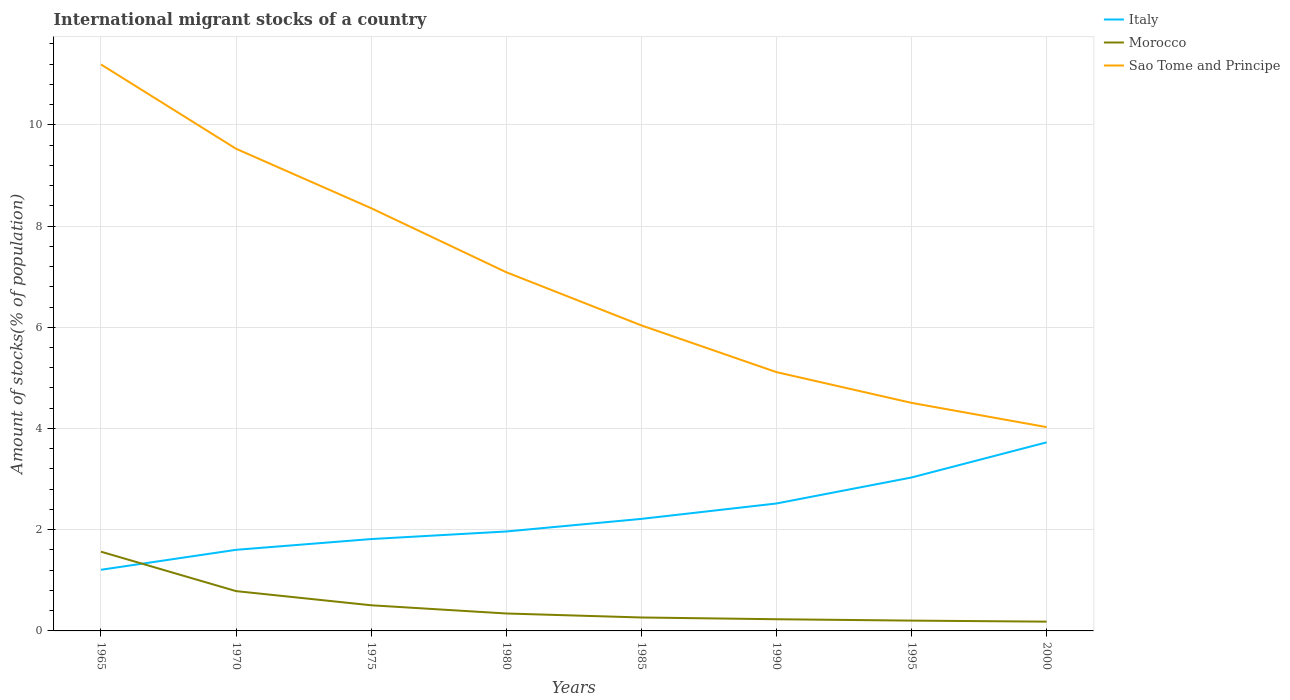Does the line corresponding to Sao Tome and Principe intersect with the line corresponding to Italy?
Your response must be concise. No. Across all years, what is the maximum amount of stocks in in Sao Tome and Principe?
Offer a very short reply. 4.03. In which year was the amount of stocks in in Italy maximum?
Provide a succinct answer. 1965. What is the total amount of stocks in in Sao Tome and Principe in the graph?
Provide a succinct answer. 6.69. What is the difference between the highest and the second highest amount of stocks in in Italy?
Your answer should be very brief. 2.52. What is the difference between the highest and the lowest amount of stocks in in Morocco?
Keep it short and to the point. 2. How many years are there in the graph?
Your answer should be compact. 8. Where does the legend appear in the graph?
Give a very brief answer. Top right. What is the title of the graph?
Provide a short and direct response. International migrant stocks of a country. What is the label or title of the X-axis?
Provide a succinct answer. Years. What is the label or title of the Y-axis?
Your response must be concise. Amount of stocks(% of population). What is the Amount of stocks(% of population) in Italy in 1965?
Your response must be concise. 1.21. What is the Amount of stocks(% of population) of Morocco in 1965?
Provide a succinct answer. 1.57. What is the Amount of stocks(% of population) in Sao Tome and Principe in 1965?
Give a very brief answer. 11.19. What is the Amount of stocks(% of population) of Italy in 1970?
Keep it short and to the point. 1.6. What is the Amount of stocks(% of population) of Morocco in 1970?
Offer a very short reply. 0.79. What is the Amount of stocks(% of population) in Sao Tome and Principe in 1970?
Offer a terse response. 9.53. What is the Amount of stocks(% of population) in Italy in 1975?
Your answer should be compact. 1.82. What is the Amount of stocks(% of population) of Morocco in 1975?
Offer a terse response. 0.51. What is the Amount of stocks(% of population) of Sao Tome and Principe in 1975?
Provide a short and direct response. 8.35. What is the Amount of stocks(% of population) of Italy in 1980?
Make the answer very short. 1.96. What is the Amount of stocks(% of population) in Morocco in 1980?
Provide a succinct answer. 0.34. What is the Amount of stocks(% of population) of Sao Tome and Principe in 1980?
Provide a succinct answer. 7.09. What is the Amount of stocks(% of population) of Italy in 1985?
Offer a very short reply. 2.21. What is the Amount of stocks(% of population) in Morocco in 1985?
Your answer should be very brief. 0.27. What is the Amount of stocks(% of population) of Sao Tome and Principe in 1985?
Ensure brevity in your answer.  6.04. What is the Amount of stocks(% of population) of Italy in 1990?
Provide a succinct answer. 2.52. What is the Amount of stocks(% of population) of Morocco in 1990?
Your response must be concise. 0.23. What is the Amount of stocks(% of population) in Sao Tome and Principe in 1990?
Make the answer very short. 5.11. What is the Amount of stocks(% of population) of Italy in 1995?
Offer a very short reply. 3.03. What is the Amount of stocks(% of population) in Morocco in 1995?
Provide a succinct answer. 0.2. What is the Amount of stocks(% of population) of Sao Tome and Principe in 1995?
Provide a short and direct response. 4.51. What is the Amount of stocks(% of population) in Italy in 2000?
Provide a succinct answer. 3.73. What is the Amount of stocks(% of population) of Morocco in 2000?
Your response must be concise. 0.18. What is the Amount of stocks(% of population) of Sao Tome and Principe in 2000?
Offer a very short reply. 4.03. Across all years, what is the maximum Amount of stocks(% of population) in Italy?
Your response must be concise. 3.73. Across all years, what is the maximum Amount of stocks(% of population) of Morocco?
Make the answer very short. 1.57. Across all years, what is the maximum Amount of stocks(% of population) in Sao Tome and Principe?
Offer a terse response. 11.19. Across all years, what is the minimum Amount of stocks(% of population) of Italy?
Ensure brevity in your answer.  1.21. Across all years, what is the minimum Amount of stocks(% of population) of Morocco?
Provide a succinct answer. 0.18. Across all years, what is the minimum Amount of stocks(% of population) of Sao Tome and Principe?
Keep it short and to the point. 4.03. What is the total Amount of stocks(% of population) in Italy in the graph?
Offer a terse response. 18.08. What is the total Amount of stocks(% of population) in Morocco in the graph?
Offer a terse response. 4.09. What is the total Amount of stocks(% of population) in Sao Tome and Principe in the graph?
Your response must be concise. 55.85. What is the difference between the Amount of stocks(% of population) in Italy in 1965 and that in 1970?
Your answer should be compact. -0.39. What is the difference between the Amount of stocks(% of population) of Morocco in 1965 and that in 1970?
Make the answer very short. 0.78. What is the difference between the Amount of stocks(% of population) of Sao Tome and Principe in 1965 and that in 1970?
Give a very brief answer. 1.67. What is the difference between the Amount of stocks(% of population) of Italy in 1965 and that in 1975?
Keep it short and to the point. -0.61. What is the difference between the Amount of stocks(% of population) of Morocco in 1965 and that in 1975?
Make the answer very short. 1.06. What is the difference between the Amount of stocks(% of population) of Sao Tome and Principe in 1965 and that in 1975?
Provide a short and direct response. 2.84. What is the difference between the Amount of stocks(% of population) of Italy in 1965 and that in 1980?
Your answer should be compact. -0.76. What is the difference between the Amount of stocks(% of population) of Morocco in 1965 and that in 1980?
Make the answer very short. 1.22. What is the difference between the Amount of stocks(% of population) of Sao Tome and Principe in 1965 and that in 1980?
Keep it short and to the point. 4.11. What is the difference between the Amount of stocks(% of population) of Italy in 1965 and that in 1985?
Give a very brief answer. -1.01. What is the difference between the Amount of stocks(% of population) in Morocco in 1965 and that in 1985?
Give a very brief answer. 1.3. What is the difference between the Amount of stocks(% of population) in Sao Tome and Principe in 1965 and that in 1985?
Provide a short and direct response. 5.16. What is the difference between the Amount of stocks(% of population) of Italy in 1965 and that in 1990?
Offer a terse response. -1.31. What is the difference between the Amount of stocks(% of population) of Morocco in 1965 and that in 1990?
Your answer should be very brief. 1.33. What is the difference between the Amount of stocks(% of population) of Sao Tome and Principe in 1965 and that in 1990?
Offer a terse response. 6.08. What is the difference between the Amount of stocks(% of population) in Italy in 1965 and that in 1995?
Make the answer very short. -1.82. What is the difference between the Amount of stocks(% of population) in Morocco in 1965 and that in 1995?
Offer a very short reply. 1.36. What is the difference between the Amount of stocks(% of population) of Sao Tome and Principe in 1965 and that in 1995?
Provide a succinct answer. 6.69. What is the difference between the Amount of stocks(% of population) in Italy in 1965 and that in 2000?
Provide a succinct answer. -2.52. What is the difference between the Amount of stocks(% of population) of Morocco in 1965 and that in 2000?
Ensure brevity in your answer.  1.38. What is the difference between the Amount of stocks(% of population) in Sao Tome and Principe in 1965 and that in 2000?
Offer a terse response. 7.17. What is the difference between the Amount of stocks(% of population) of Italy in 1970 and that in 1975?
Offer a very short reply. -0.21. What is the difference between the Amount of stocks(% of population) in Morocco in 1970 and that in 1975?
Give a very brief answer. 0.28. What is the difference between the Amount of stocks(% of population) in Sao Tome and Principe in 1970 and that in 1975?
Ensure brevity in your answer.  1.17. What is the difference between the Amount of stocks(% of population) of Italy in 1970 and that in 1980?
Make the answer very short. -0.36. What is the difference between the Amount of stocks(% of population) in Morocco in 1970 and that in 1980?
Provide a succinct answer. 0.44. What is the difference between the Amount of stocks(% of population) in Sao Tome and Principe in 1970 and that in 1980?
Keep it short and to the point. 2.44. What is the difference between the Amount of stocks(% of population) in Italy in 1970 and that in 1985?
Your answer should be compact. -0.61. What is the difference between the Amount of stocks(% of population) of Morocco in 1970 and that in 1985?
Your response must be concise. 0.52. What is the difference between the Amount of stocks(% of population) of Sao Tome and Principe in 1970 and that in 1985?
Your response must be concise. 3.49. What is the difference between the Amount of stocks(% of population) in Italy in 1970 and that in 1990?
Your answer should be very brief. -0.92. What is the difference between the Amount of stocks(% of population) in Morocco in 1970 and that in 1990?
Provide a succinct answer. 0.56. What is the difference between the Amount of stocks(% of population) of Sao Tome and Principe in 1970 and that in 1990?
Give a very brief answer. 4.41. What is the difference between the Amount of stocks(% of population) in Italy in 1970 and that in 1995?
Keep it short and to the point. -1.43. What is the difference between the Amount of stocks(% of population) in Morocco in 1970 and that in 1995?
Make the answer very short. 0.58. What is the difference between the Amount of stocks(% of population) in Sao Tome and Principe in 1970 and that in 1995?
Make the answer very short. 5.02. What is the difference between the Amount of stocks(% of population) in Italy in 1970 and that in 2000?
Offer a very short reply. -2.12. What is the difference between the Amount of stocks(% of population) in Morocco in 1970 and that in 2000?
Ensure brevity in your answer.  0.6. What is the difference between the Amount of stocks(% of population) in Sao Tome and Principe in 1970 and that in 2000?
Your answer should be very brief. 5.5. What is the difference between the Amount of stocks(% of population) in Italy in 1975 and that in 1980?
Keep it short and to the point. -0.15. What is the difference between the Amount of stocks(% of population) in Morocco in 1975 and that in 1980?
Make the answer very short. 0.16. What is the difference between the Amount of stocks(% of population) in Sao Tome and Principe in 1975 and that in 1980?
Provide a short and direct response. 1.27. What is the difference between the Amount of stocks(% of population) in Italy in 1975 and that in 1985?
Provide a short and direct response. -0.4. What is the difference between the Amount of stocks(% of population) of Morocco in 1975 and that in 1985?
Your answer should be very brief. 0.24. What is the difference between the Amount of stocks(% of population) in Sao Tome and Principe in 1975 and that in 1985?
Give a very brief answer. 2.32. What is the difference between the Amount of stocks(% of population) of Italy in 1975 and that in 1990?
Your answer should be very brief. -0.7. What is the difference between the Amount of stocks(% of population) of Morocco in 1975 and that in 1990?
Offer a very short reply. 0.28. What is the difference between the Amount of stocks(% of population) in Sao Tome and Principe in 1975 and that in 1990?
Make the answer very short. 3.24. What is the difference between the Amount of stocks(% of population) in Italy in 1975 and that in 1995?
Your answer should be very brief. -1.22. What is the difference between the Amount of stocks(% of population) of Morocco in 1975 and that in 1995?
Offer a very short reply. 0.3. What is the difference between the Amount of stocks(% of population) in Sao Tome and Principe in 1975 and that in 1995?
Make the answer very short. 3.85. What is the difference between the Amount of stocks(% of population) of Italy in 1975 and that in 2000?
Provide a succinct answer. -1.91. What is the difference between the Amount of stocks(% of population) in Morocco in 1975 and that in 2000?
Keep it short and to the point. 0.32. What is the difference between the Amount of stocks(% of population) of Sao Tome and Principe in 1975 and that in 2000?
Provide a short and direct response. 4.33. What is the difference between the Amount of stocks(% of population) of Italy in 1980 and that in 1985?
Your response must be concise. -0.25. What is the difference between the Amount of stocks(% of population) of Morocco in 1980 and that in 1985?
Keep it short and to the point. 0.08. What is the difference between the Amount of stocks(% of population) in Sao Tome and Principe in 1980 and that in 1985?
Provide a succinct answer. 1.05. What is the difference between the Amount of stocks(% of population) in Italy in 1980 and that in 1990?
Provide a short and direct response. -0.55. What is the difference between the Amount of stocks(% of population) of Morocco in 1980 and that in 1990?
Ensure brevity in your answer.  0.11. What is the difference between the Amount of stocks(% of population) of Sao Tome and Principe in 1980 and that in 1990?
Make the answer very short. 1.97. What is the difference between the Amount of stocks(% of population) in Italy in 1980 and that in 1995?
Your response must be concise. -1.07. What is the difference between the Amount of stocks(% of population) in Morocco in 1980 and that in 1995?
Your answer should be very brief. 0.14. What is the difference between the Amount of stocks(% of population) of Sao Tome and Principe in 1980 and that in 1995?
Keep it short and to the point. 2.58. What is the difference between the Amount of stocks(% of population) in Italy in 1980 and that in 2000?
Offer a terse response. -1.76. What is the difference between the Amount of stocks(% of population) of Morocco in 1980 and that in 2000?
Keep it short and to the point. 0.16. What is the difference between the Amount of stocks(% of population) of Sao Tome and Principe in 1980 and that in 2000?
Make the answer very short. 3.06. What is the difference between the Amount of stocks(% of population) of Italy in 1985 and that in 1990?
Your answer should be compact. -0.3. What is the difference between the Amount of stocks(% of population) of Morocco in 1985 and that in 1990?
Your response must be concise. 0.03. What is the difference between the Amount of stocks(% of population) of Sao Tome and Principe in 1985 and that in 1990?
Make the answer very short. 0.92. What is the difference between the Amount of stocks(% of population) in Italy in 1985 and that in 1995?
Make the answer very short. -0.82. What is the difference between the Amount of stocks(% of population) in Morocco in 1985 and that in 1995?
Your answer should be very brief. 0.06. What is the difference between the Amount of stocks(% of population) in Sao Tome and Principe in 1985 and that in 1995?
Ensure brevity in your answer.  1.53. What is the difference between the Amount of stocks(% of population) in Italy in 1985 and that in 2000?
Your answer should be very brief. -1.51. What is the difference between the Amount of stocks(% of population) in Morocco in 1985 and that in 2000?
Ensure brevity in your answer.  0.08. What is the difference between the Amount of stocks(% of population) in Sao Tome and Principe in 1985 and that in 2000?
Make the answer very short. 2.01. What is the difference between the Amount of stocks(% of population) of Italy in 1990 and that in 1995?
Make the answer very short. -0.51. What is the difference between the Amount of stocks(% of population) in Morocco in 1990 and that in 1995?
Ensure brevity in your answer.  0.03. What is the difference between the Amount of stocks(% of population) in Sao Tome and Principe in 1990 and that in 1995?
Offer a terse response. 0.61. What is the difference between the Amount of stocks(% of population) of Italy in 1990 and that in 2000?
Give a very brief answer. -1.21. What is the difference between the Amount of stocks(% of population) of Morocco in 1990 and that in 2000?
Keep it short and to the point. 0.05. What is the difference between the Amount of stocks(% of population) of Sao Tome and Principe in 1990 and that in 2000?
Offer a terse response. 1.09. What is the difference between the Amount of stocks(% of population) of Italy in 1995 and that in 2000?
Your response must be concise. -0.69. What is the difference between the Amount of stocks(% of population) of Morocco in 1995 and that in 2000?
Offer a very short reply. 0.02. What is the difference between the Amount of stocks(% of population) in Sao Tome and Principe in 1995 and that in 2000?
Your answer should be compact. 0.48. What is the difference between the Amount of stocks(% of population) of Italy in 1965 and the Amount of stocks(% of population) of Morocco in 1970?
Your answer should be compact. 0.42. What is the difference between the Amount of stocks(% of population) of Italy in 1965 and the Amount of stocks(% of population) of Sao Tome and Principe in 1970?
Offer a terse response. -8.32. What is the difference between the Amount of stocks(% of population) of Morocco in 1965 and the Amount of stocks(% of population) of Sao Tome and Principe in 1970?
Make the answer very short. -7.96. What is the difference between the Amount of stocks(% of population) of Italy in 1965 and the Amount of stocks(% of population) of Morocco in 1975?
Your answer should be very brief. 0.7. What is the difference between the Amount of stocks(% of population) in Italy in 1965 and the Amount of stocks(% of population) in Sao Tome and Principe in 1975?
Your response must be concise. -7.14. What is the difference between the Amount of stocks(% of population) of Morocco in 1965 and the Amount of stocks(% of population) of Sao Tome and Principe in 1975?
Keep it short and to the point. -6.79. What is the difference between the Amount of stocks(% of population) of Italy in 1965 and the Amount of stocks(% of population) of Morocco in 1980?
Give a very brief answer. 0.86. What is the difference between the Amount of stocks(% of population) of Italy in 1965 and the Amount of stocks(% of population) of Sao Tome and Principe in 1980?
Offer a very short reply. -5.88. What is the difference between the Amount of stocks(% of population) of Morocco in 1965 and the Amount of stocks(% of population) of Sao Tome and Principe in 1980?
Your answer should be very brief. -5.52. What is the difference between the Amount of stocks(% of population) in Italy in 1965 and the Amount of stocks(% of population) in Morocco in 1985?
Give a very brief answer. 0.94. What is the difference between the Amount of stocks(% of population) of Italy in 1965 and the Amount of stocks(% of population) of Sao Tome and Principe in 1985?
Give a very brief answer. -4.83. What is the difference between the Amount of stocks(% of population) in Morocco in 1965 and the Amount of stocks(% of population) in Sao Tome and Principe in 1985?
Keep it short and to the point. -4.47. What is the difference between the Amount of stocks(% of population) of Italy in 1965 and the Amount of stocks(% of population) of Morocco in 1990?
Provide a succinct answer. 0.98. What is the difference between the Amount of stocks(% of population) in Italy in 1965 and the Amount of stocks(% of population) in Sao Tome and Principe in 1990?
Provide a short and direct response. -3.91. What is the difference between the Amount of stocks(% of population) in Morocco in 1965 and the Amount of stocks(% of population) in Sao Tome and Principe in 1990?
Keep it short and to the point. -3.55. What is the difference between the Amount of stocks(% of population) of Italy in 1965 and the Amount of stocks(% of population) of Morocco in 1995?
Ensure brevity in your answer.  1. What is the difference between the Amount of stocks(% of population) in Italy in 1965 and the Amount of stocks(% of population) in Sao Tome and Principe in 1995?
Your response must be concise. -3.3. What is the difference between the Amount of stocks(% of population) in Morocco in 1965 and the Amount of stocks(% of population) in Sao Tome and Principe in 1995?
Offer a terse response. -2.94. What is the difference between the Amount of stocks(% of population) in Italy in 1965 and the Amount of stocks(% of population) in Morocco in 2000?
Ensure brevity in your answer.  1.02. What is the difference between the Amount of stocks(% of population) in Italy in 1965 and the Amount of stocks(% of population) in Sao Tome and Principe in 2000?
Your answer should be compact. -2.82. What is the difference between the Amount of stocks(% of population) in Morocco in 1965 and the Amount of stocks(% of population) in Sao Tome and Principe in 2000?
Provide a short and direct response. -2.46. What is the difference between the Amount of stocks(% of population) of Italy in 1970 and the Amount of stocks(% of population) of Morocco in 1975?
Provide a short and direct response. 1.1. What is the difference between the Amount of stocks(% of population) in Italy in 1970 and the Amount of stocks(% of population) in Sao Tome and Principe in 1975?
Your answer should be very brief. -6.75. What is the difference between the Amount of stocks(% of population) of Morocco in 1970 and the Amount of stocks(% of population) of Sao Tome and Principe in 1975?
Your answer should be very brief. -7.57. What is the difference between the Amount of stocks(% of population) of Italy in 1970 and the Amount of stocks(% of population) of Morocco in 1980?
Your answer should be very brief. 1.26. What is the difference between the Amount of stocks(% of population) in Italy in 1970 and the Amount of stocks(% of population) in Sao Tome and Principe in 1980?
Keep it short and to the point. -5.49. What is the difference between the Amount of stocks(% of population) of Morocco in 1970 and the Amount of stocks(% of population) of Sao Tome and Principe in 1980?
Your answer should be very brief. -6.3. What is the difference between the Amount of stocks(% of population) of Italy in 1970 and the Amount of stocks(% of population) of Morocco in 1985?
Ensure brevity in your answer.  1.34. What is the difference between the Amount of stocks(% of population) of Italy in 1970 and the Amount of stocks(% of population) of Sao Tome and Principe in 1985?
Provide a succinct answer. -4.43. What is the difference between the Amount of stocks(% of population) of Morocco in 1970 and the Amount of stocks(% of population) of Sao Tome and Principe in 1985?
Offer a terse response. -5.25. What is the difference between the Amount of stocks(% of population) of Italy in 1970 and the Amount of stocks(% of population) of Morocco in 1990?
Make the answer very short. 1.37. What is the difference between the Amount of stocks(% of population) in Italy in 1970 and the Amount of stocks(% of population) in Sao Tome and Principe in 1990?
Offer a terse response. -3.51. What is the difference between the Amount of stocks(% of population) in Morocco in 1970 and the Amount of stocks(% of population) in Sao Tome and Principe in 1990?
Offer a very short reply. -4.33. What is the difference between the Amount of stocks(% of population) of Italy in 1970 and the Amount of stocks(% of population) of Morocco in 1995?
Your response must be concise. 1.4. What is the difference between the Amount of stocks(% of population) in Italy in 1970 and the Amount of stocks(% of population) in Sao Tome and Principe in 1995?
Offer a very short reply. -2.9. What is the difference between the Amount of stocks(% of population) of Morocco in 1970 and the Amount of stocks(% of population) of Sao Tome and Principe in 1995?
Give a very brief answer. -3.72. What is the difference between the Amount of stocks(% of population) of Italy in 1970 and the Amount of stocks(% of population) of Morocco in 2000?
Offer a terse response. 1.42. What is the difference between the Amount of stocks(% of population) in Italy in 1970 and the Amount of stocks(% of population) in Sao Tome and Principe in 2000?
Your response must be concise. -2.42. What is the difference between the Amount of stocks(% of population) of Morocco in 1970 and the Amount of stocks(% of population) of Sao Tome and Principe in 2000?
Offer a very short reply. -3.24. What is the difference between the Amount of stocks(% of population) in Italy in 1975 and the Amount of stocks(% of population) in Morocco in 1980?
Your response must be concise. 1.47. What is the difference between the Amount of stocks(% of population) of Italy in 1975 and the Amount of stocks(% of population) of Sao Tome and Principe in 1980?
Ensure brevity in your answer.  -5.27. What is the difference between the Amount of stocks(% of population) of Morocco in 1975 and the Amount of stocks(% of population) of Sao Tome and Principe in 1980?
Give a very brief answer. -6.58. What is the difference between the Amount of stocks(% of population) in Italy in 1975 and the Amount of stocks(% of population) in Morocco in 1985?
Give a very brief answer. 1.55. What is the difference between the Amount of stocks(% of population) in Italy in 1975 and the Amount of stocks(% of population) in Sao Tome and Principe in 1985?
Ensure brevity in your answer.  -4.22. What is the difference between the Amount of stocks(% of population) of Morocco in 1975 and the Amount of stocks(% of population) of Sao Tome and Principe in 1985?
Provide a succinct answer. -5.53. What is the difference between the Amount of stocks(% of population) in Italy in 1975 and the Amount of stocks(% of population) in Morocco in 1990?
Offer a terse response. 1.58. What is the difference between the Amount of stocks(% of population) of Italy in 1975 and the Amount of stocks(% of population) of Sao Tome and Principe in 1990?
Your response must be concise. -3.3. What is the difference between the Amount of stocks(% of population) in Morocco in 1975 and the Amount of stocks(% of population) in Sao Tome and Principe in 1990?
Provide a succinct answer. -4.61. What is the difference between the Amount of stocks(% of population) of Italy in 1975 and the Amount of stocks(% of population) of Morocco in 1995?
Ensure brevity in your answer.  1.61. What is the difference between the Amount of stocks(% of population) of Italy in 1975 and the Amount of stocks(% of population) of Sao Tome and Principe in 1995?
Ensure brevity in your answer.  -2.69. What is the difference between the Amount of stocks(% of population) in Morocco in 1975 and the Amount of stocks(% of population) in Sao Tome and Principe in 1995?
Offer a very short reply. -4. What is the difference between the Amount of stocks(% of population) in Italy in 1975 and the Amount of stocks(% of population) in Morocco in 2000?
Offer a terse response. 1.63. What is the difference between the Amount of stocks(% of population) of Italy in 1975 and the Amount of stocks(% of population) of Sao Tome and Principe in 2000?
Ensure brevity in your answer.  -2.21. What is the difference between the Amount of stocks(% of population) in Morocco in 1975 and the Amount of stocks(% of population) in Sao Tome and Principe in 2000?
Offer a terse response. -3.52. What is the difference between the Amount of stocks(% of population) in Italy in 1980 and the Amount of stocks(% of population) in Morocco in 1985?
Your answer should be very brief. 1.7. What is the difference between the Amount of stocks(% of population) of Italy in 1980 and the Amount of stocks(% of population) of Sao Tome and Principe in 1985?
Your answer should be very brief. -4.07. What is the difference between the Amount of stocks(% of population) in Morocco in 1980 and the Amount of stocks(% of population) in Sao Tome and Principe in 1985?
Give a very brief answer. -5.69. What is the difference between the Amount of stocks(% of population) in Italy in 1980 and the Amount of stocks(% of population) in Morocco in 1990?
Keep it short and to the point. 1.73. What is the difference between the Amount of stocks(% of population) in Italy in 1980 and the Amount of stocks(% of population) in Sao Tome and Principe in 1990?
Keep it short and to the point. -3.15. What is the difference between the Amount of stocks(% of population) of Morocco in 1980 and the Amount of stocks(% of population) of Sao Tome and Principe in 1990?
Provide a short and direct response. -4.77. What is the difference between the Amount of stocks(% of population) in Italy in 1980 and the Amount of stocks(% of population) in Morocco in 1995?
Provide a short and direct response. 1.76. What is the difference between the Amount of stocks(% of population) of Italy in 1980 and the Amount of stocks(% of population) of Sao Tome and Principe in 1995?
Provide a short and direct response. -2.54. What is the difference between the Amount of stocks(% of population) of Morocco in 1980 and the Amount of stocks(% of population) of Sao Tome and Principe in 1995?
Provide a succinct answer. -4.16. What is the difference between the Amount of stocks(% of population) in Italy in 1980 and the Amount of stocks(% of population) in Morocco in 2000?
Offer a very short reply. 1.78. What is the difference between the Amount of stocks(% of population) of Italy in 1980 and the Amount of stocks(% of population) of Sao Tome and Principe in 2000?
Provide a short and direct response. -2.06. What is the difference between the Amount of stocks(% of population) in Morocco in 1980 and the Amount of stocks(% of population) in Sao Tome and Principe in 2000?
Offer a very short reply. -3.68. What is the difference between the Amount of stocks(% of population) of Italy in 1985 and the Amount of stocks(% of population) of Morocco in 1990?
Make the answer very short. 1.98. What is the difference between the Amount of stocks(% of population) of Italy in 1985 and the Amount of stocks(% of population) of Sao Tome and Principe in 1990?
Ensure brevity in your answer.  -2.9. What is the difference between the Amount of stocks(% of population) in Morocco in 1985 and the Amount of stocks(% of population) in Sao Tome and Principe in 1990?
Your answer should be compact. -4.85. What is the difference between the Amount of stocks(% of population) in Italy in 1985 and the Amount of stocks(% of population) in Morocco in 1995?
Your answer should be compact. 2.01. What is the difference between the Amount of stocks(% of population) in Italy in 1985 and the Amount of stocks(% of population) in Sao Tome and Principe in 1995?
Your answer should be very brief. -2.29. What is the difference between the Amount of stocks(% of population) in Morocco in 1985 and the Amount of stocks(% of population) in Sao Tome and Principe in 1995?
Offer a terse response. -4.24. What is the difference between the Amount of stocks(% of population) of Italy in 1985 and the Amount of stocks(% of population) of Morocco in 2000?
Make the answer very short. 2.03. What is the difference between the Amount of stocks(% of population) in Italy in 1985 and the Amount of stocks(% of population) in Sao Tome and Principe in 2000?
Provide a short and direct response. -1.81. What is the difference between the Amount of stocks(% of population) of Morocco in 1985 and the Amount of stocks(% of population) of Sao Tome and Principe in 2000?
Offer a terse response. -3.76. What is the difference between the Amount of stocks(% of population) of Italy in 1990 and the Amount of stocks(% of population) of Morocco in 1995?
Your answer should be very brief. 2.31. What is the difference between the Amount of stocks(% of population) in Italy in 1990 and the Amount of stocks(% of population) in Sao Tome and Principe in 1995?
Your response must be concise. -1.99. What is the difference between the Amount of stocks(% of population) of Morocco in 1990 and the Amount of stocks(% of population) of Sao Tome and Principe in 1995?
Your answer should be compact. -4.28. What is the difference between the Amount of stocks(% of population) in Italy in 1990 and the Amount of stocks(% of population) in Morocco in 2000?
Ensure brevity in your answer.  2.33. What is the difference between the Amount of stocks(% of population) of Italy in 1990 and the Amount of stocks(% of population) of Sao Tome and Principe in 2000?
Ensure brevity in your answer.  -1.51. What is the difference between the Amount of stocks(% of population) in Morocco in 1990 and the Amount of stocks(% of population) in Sao Tome and Principe in 2000?
Provide a short and direct response. -3.8. What is the difference between the Amount of stocks(% of population) in Italy in 1995 and the Amount of stocks(% of population) in Morocco in 2000?
Provide a short and direct response. 2.85. What is the difference between the Amount of stocks(% of population) of Italy in 1995 and the Amount of stocks(% of population) of Sao Tome and Principe in 2000?
Your response must be concise. -1. What is the difference between the Amount of stocks(% of population) of Morocco in 1995 and the Amount of stocks(% of population) of Sao Tome and Principe in 2000?
Ensure brevity in your answer.  -3.82. What is the average Amount of stocks(% of population) in Italy per year?
Provide a short and direct response. 2.26. What is the average Amount of stocks(% of population) in Morocco per year?
Your answer should be compact. 0.51. What is the average Amount of stocks(% of population) of Sao Tome and Principe per year?
Offer a very short reply. 6.98. In the year 1965, what is the difference between the Amount of stocks(% of population) in Italy and Amount of stocks(% of population) in Morocco?
Offer a terse response. -0.36. In the year 1965, what is the difference between the Amount of stocks(% of population) of Italy and Amount of stocks(% of population) of Sao Tome and Principe?
Your answer should be very brief. -9.99. In the year 1965, what is the difference between the Amount of stocks(% of population) in Morocco and Amount of stocks(% of population) in Sao Tome and Principe?
Offer a terse response. -9.63. In the year 1970, what is the difference between the Amount of stocks(% of population) in Italy and Amount of stocks(% of population) in Morocco?
Your response must be concise. 0.82. In the year 1970, what is the difference between the Amount of stocks(% of population) in Italy and Amount of stocks(% of population) in Sao Tome and Principe?
Ensure brevity in your answer.  -7.92. In the year 1970, what is the difference between the Amount of stocks(% of population) of Morocco and Amount of stocks(% of population) of Sao Tome and Principe?
Ensure brevity in your answer.  -8.74. In the year 1975, what is the difference between the Amount of stocks(% of population) of Italy and Amount of stocks(% of population) of Morocco?
Give a very brief answer. 1.31. In the year 1975, what is the difference between the Amount of stocks(% of population) of Italy and Amount of stocks(% of population) of Sao Tome and Principe?
Keep it short and to the point. -6.54. In the year 1975, what is the difference between the Amount of stocks(% of population) of Morocco and Amount of stocks(% of population) of Sao Tome and Principe?
Offer a very short reply. -7.85. In the year 1980, what is the difference between the Amount of stocks(% of population) in Italy and Amount of stocks(% of population) in Morocco?
Your answer should be compact. 1.62. In the year 1980, what is the difference between the Amount of stocks(% of population) in Italy and Amount of stocks(% of population) in Sao Tome and Principe?
Offer a very short reply. -5.12. In the year 1980, what is the difference between the Amount of stocks(% of population) in Morocco and Amount of stocks(% of population) in Sao Tome and Principe?
Make the answer very short. -6.74. In the year 1985, what is the difference between the Amount of stocks(% of population) in Italy and Amount of stocks(% of population) in Morocco?
Offer a terse response. 1.95. In the year 1985, what is the difference between the Amount of stocks(% of population) of Italy and Amount of stocks(% of population) of Sao Tome and Principe?
Make the answer very short. -3.82. In the year 1985, what is the difference between the Amount of stocks(% of population) in Morocco and Amount of stocks(% of population) in Sao Tome and Principe?
Offer a very short reply. -5.77. In the year 1990, what is the difference between the Amount of stocks(% of population) in Italy and Amount of stocks(% of population) in Morocco?
Ensure brevity in your answer.  2.29. In the year 1990, what is the difference between the Amount of stocks(% of population) of Italy and Amount of stocks(% of population) of Sao Tome and Principe?
Your answer should be very brief. -2.6. In the year 1990, what is the difference between the Amount of stocks(% of population) of Morocco and Amount of stocks(% of population) of Sao Tome and Principe?
Your response must be concise. -4.88. In the year 1995, what is the difference between the Amount of stocks(% of population) in Italy and Amount of stocks(% of population) in Morocco?
Offer a terse response. 2.83. In the year 1995, what is the difference between the Amount of stocks(% of population) of Italy and Amount of stocks(% of population) of Sao Tome and Principe?
Offer a terse response. -1.47. In the year 1995, what is the difference between the Amount of stocks(% of population) of Morocco and Amount of stocks(% of population) of Sao Tome and Principe?
Provide a short and direct response. -4.3. In the year 2000, what is the difference between the Amount of stocks(% of population) in Italy and Amount of stocks(% of population) in Morocco?
Provide a short and direct response. 3.54. In the year 2000, what is the difference between the Amount of stocks(% of population) of Italy and Amount of stocks(% of population) of Sao Tome and Principe?
Offer a very short reply. -0.3. In the year 2000, what is the difference between the Amount of stocks(% of population) of Morocco and Amount of stocks(% of population) of Sao Tome and Principe?
Keep it short and to the point. -3.84. What is the ratio of the Amount of stocks(% of population) in Italy in 1965 to that in 1970?
Your response must be concise. 0.75. What is the ratio of the Amount of stocks(% of population) of Morocco in 1965 to that in 1970?
Keep it short and to the point. 1.99. What is the ratio of the Amount of stocks(% of population) of Sao Tome and Principe in 1965 to that in 1970?
Provide a short and direct response. 1.17. What is the ratio of the Amount of stocks(% of population) of Italy in 1965 to that in 1975?
Your answer should be compact. 0.67. What is the ratio of the Amount of stocks(% of population) in Morocco in 1965 to that in 1975?
Your answer should be very brief. 3.09. What is the ratio of the Amount of stocks(% of population) in Sao Tome and Principe in 1965 to that in 1975?
Make the answer very short. 1.34. What is the ratio of the Amount of stocks(% of population) of Italy in 1965 to that in 1980?
Offer a terse response. 0.61. What is the ratio of the Amount of stocks(% of population) of Morocco in 1965 to that in 1980?
Your answer should be very brief. 4.54. What is the ratio of the Amount of stocks(% of population) of Sao Tome and Principe in 1965 to that in 1980?
Keep it short and to the point. 1.58. What is the ratio of the Amount of stocks(% of population) in Italy in 1965 to that in 1985?
Keep it short and to the point. 0.55. What is the ratio of the Amount of stocks(% of population) in Morocco in 1965 to that in 1985?
Your answer should be very brief. 5.9. What is the ratio of the Amount of stocks(% of population) of Sao Tome and Principe in 1965 to that in 1985?
Make the answer very short. 1.85. What is the ratio of the Amount of stocks(% of population) of Italy in 1965 to that in 1990?
Your answer should be very brief. 0.48. What is the ratio of the Amount of stocks(% of population) in Morocco in 1965 to that in 1990?
Your answer should be very brief. 6.78. What is the ratio of the Amount of stocks(% of population) in Sao Tome and Principe in 1965 to that in 1990?
Make the answer very short. 2.19. What is the ratio of the Amount of stocks(% of population) in Italy in 1965 to that in 1995?
Your answer should be very brief. 0.4. What is the ratio of the Amount of stocks(% of population) in Morocco in 1965 to that in 1995?
Offer a very short reply. 7.69. What is the ratio of the Amount of stocks(% of population) of Sao Tome and Principe in 1965 to that in 1995?
Your response must be concise. 2.48. What is the ratio of the Amount of stocks(% of population) in Italy in 1965 to that in 2000?
Provide a short and direct response. 0.32. What is the ratio of the Amount of stocks(% of population) in Morocco in 1965 to that in 2000?
Your answer should be compact. 8.53. What is the ratio of the Amount of stocks(% of population) of Sao Tome and Principe in 1965 to that in 2000?
Give a very brief answer. 2.78. What is the ratio of the Amount of stocks(% of population) of Italy in 1970 to that in 1975?
Offer a terse response. 0.88. What is the ratio of the Amount of stocks(% of population) in Morocco in 1970 to that in 1975?
Offer a very short reply. 1.55. What is the ratio of the Amount of stocks(% of population) of Sao Tome and Principe in 1970 to that in 1975?
Make the answer very short. 1.14. What is the ratio of the Amount of stocks(% of population) in Italy in 1970 to that in 1980?
Your answer should be very brief. 0.82. What is the ratio of the Amount of stocks(% of population) in Morocco in 1970 to that in 1980?
Your response must be concise. 2.28. What is the ratio of the Amount of stocks(% of population) in Sao Tome and Principe in 1970 to that in 1980?
Your response must be concise. 1.34. What is the ratio of the Amount of stocks(% of population) in Italy in 1970 to that in 1985?
Offer a terse response. 0.72. What is the ratio of the Amount of stocks(% of population) in Morocco in 1970 to that in 1985?
Keep it short and to the point. 2.96. What is the ratio of the Amount of stocks(% of population) of Sao Tome and Principe in 1970 to that in 1985?
Keep it short and to the point. 1.58. What is the ratio of the Amount of stocks(% of population) of Italy in 1970 to that in 1990?
Keep it short and to the point. 0.64. What is the ratio of the Amount of stocks(% of population) in Morocco in 1970 to that in 1990?
Your answer should be very brief. 3.41. What is the ratio of the Amount of stocks(% of population) of Sao Tome and Principe in 1970 to that in 1990?
Make the answer very short. 1.86. What is the ratio of the Amount of stocks(% of population) of Italy in 1970 to that in 1995?
Make the answer very short. 0.53. What is the ratio of the Amount of stocks(% of population) of Morocco in 1970 to that in 1995?
Your answer should be compact. 3.86. What is the ratio of the Amount of stocks(% of population) in Sao Tome and Principe in 1970 to that in 1995?
Provide a succinct answer. 2.11. What is the ratio of the Amount of stocks(% of population) of Italy in 1970 to that in 2000?
Keep it short and to the point. 0.43. What is the ratio of the Amount of stocks(% of population) in Morocco in 1970 to that in 2000?
Your answer should be compact. 4.29. What is the ratio of the Amount of stocks(% of population) of Sao Tome and Principe in 1970 to that in 2000?
Make the answer very short. 2.37. What is the ratio of the Amount of stocks(% of population) in Italy in 1975 to that in 1980?
Ensure brevity in your answer.  0.92. What is the ratio of the Amount of stocks(% of population) in Morocco in 1975 to that in 1980?
Your answer should be very brief. 1.47. What is the ratio of the Amount of stocks(% of population) in Sao Tome and Principe in 1975 to that in 1980?
Offer a very short reply. 1.18. What is the ratio of the Amount of stocks(% of population) in Italy in 1975 to that in 1985?
Provide a short and direct response. 0.82. What is the ratio of the Amount of stocks(% of population) in Morocco in 1975 to that in 1985?
Ensure brevity in your answer.  1.91. What is the ratio of the Amount of stocks(% of population) in Sao Tome and Principe in 1975 to that in 1985?
Offer a terse response. 1.38. What is the ratio of the Amount of stocks(% of population) of Italy in 1975 to that in 1990?
Your answer should be compact. 0.72. What is the ratio of the Amount of stocks(% of population) in Morocco in 1975 to that in 1990?
Your answer should be compact. 2.2. What is the ratio of the Amount of stocks(% of population) in Sao Tome and Principe in 1975 to that in 1990?
Ensure brevity in your answer.  1.63. What is the ratio of the Amount of stocks(% of population) of Italy in 1975 to that in 1995?
Provide a short and direct response. 0.6. What is the ratio of the Amount of stocks(% of population) of Morocco in 1975 to that in 1995?
Your answer should be very brief. 2.49. What is the ratio of the Amount of stocks(% of population) of Sao Tome and Principe in 1975 to that in 1995?
Offer a terse response. 1.85. What is the ratio of the Amount of stocks(% of population) in Italy in 1975 to that in 2000?
Give a very brief answer. 0.49. What is the ratio of the Amount of stocks(% of population) in Morocco in 1975 to that in 2000?
Keep it short and to the point. 2.76. What is the ratio of the Amount of stocks(% of population) in Sao Tome and Principe in 1975 to that in 2000?
Keep it short and to the point. 2.07. What is the ratio of the Amount of stocks(% of population) in Italy in 1980 to that in 1985?
Offer a very short reply. 0.89. What is the ratio of the Amount of stocks(% of population) of Morocco in 1980 to that in 1985?
Make the answer very short. 1.3. What is the ratio of the Amount of stocks(% of population) in Sao Tome and Principe in 1980 to that in 1985?
Your answer should be compact. 1.17. What is the ratio of the Amount of stocks(% of population) in Italy in 1980 to that in 1990?
Keep it short and to the point. 0.78. What is the ratio of the Amount of stocks(% of population) of Morocco in 1980 to that in 1990?
Ensure brevity in your answer.  1.49. What is the ratio of the Amount of stocks(% of population) in Sao Tome and Principe in 1980 to that in 1990?
Ensure brevity in your answer.  1.39. What is the ratio of the Amount of stocks(% of population) in Italy in 1980 to that in 1995?
Offer a very short reply. 0.65. What is the ratio of the Amount of stocks(% of population) in Morocco in 1980 to that in 1995?
Your response must be concise. 1.69. What is the ratio of the Amount of stocks(% of population) in Sao Tome and Principe in 1980 to that in 1995?
Your answer should be compact. 1.57. What is the ratio of the Amount of stocks(% of population) of Italy in 1980 to that in 2000?
Offer a very short reply. 0.53. What is the ratio of the Amount of stocks(% of population) in Morocco in 1980 to that in 2000?
Offer a very short reply. 1.88. What is the ratio of the Amount of stocks(% of population) of Sao Tome and Principe in 1980 to that in 2000?
Keep it short and to the point. 1.76. What is the ratio of the Amount of stocks(% of population) of Italy in 1985 to that in 1990?
Ensure brevity in your answer.  0.88. What is the ratio of the Amount of stocks(% of population) of Morocco in 1985 to that in 1990?
Your response must be concise. 1.15. What is the ratio of the Amount of stocks(% of population) in Sao Tome and Principe in 1985 to that in 1990?
Offer a terse response. 1.18. What is the ratio of the Amount of stocks(% of population) in Italy in 1985 to that in 1995?
Your response must be concise. 0.73. What is the ratio of the Amount of stocks(% of population) of Morocco in 1985 to that in 1995?
Keep it short and to the point. 1.3. What is the ratio of the Amount of stocks(% of population) in Sao Tome and Principe in 1985 to that in 1995?
Your answer should be very brief. 1.34. What is the ratio of the Amount of stocks(% of population) in Italy in 1985 to that in 2000?
Give a very brief answer. 0.59. What is the ratio of the Amount of stocks(% of population) in Morocco in 1985 to that in 2000?
Provide a succinct answer. 1.45. What is the ratio of the Amount of stocks(% of population) in Sao Tome and Principe in 1985 to that in 2000?
Offer a terse response. 1.5. What is the ratio of the Amount of stocks(% of population) of Italy in 1990 to that in 1995?
Give a very brief answer. 0.83. What is the ratio of the Amount of stocks(% of population) of Morocco in 1990 to that in 1995?
Your answer should be very brief. 1.13. What is the ratio of the Amount of stocks(% of population) in Sao Tome and Principe in 1990 to that in 1995?
Give a very brief answer. 1.13. What is the ratio of the Amount of stocks(% of population) of Italy in 1990 to that in 2000?
Offer a terse response. 0.68. What is the ratio of the Amount of stocks(% of population) in Morocco in 1990 to that in 2000?
Keep it short and to the point. 1.26. What is the ratio of the Amount of stocks(% of population) in Sao Tome and Principe in 1990 to that in 2000?
Provide a succinct answer. 1.27. What is the ratio of the Amount of stocks(% of population) in Italy in 1995 to that in 2000?
Offer a terse response. 0.81. What is the ratio of the Amount of stocks(% of population) in Morocco in 1995 to that in 2000?
Your response must be concise. 1.11. What is the ratio of the Amount of stocks(% of population) in Sao Tome and Principe in 1995 to that in 2000?
Your answer should be compact. 1.12. What is the difference between the highest and the second highest Amount of stocks(% of population) in Italy?
Offer a terse response. 0.69. What is the difference between the highest and the second highest Amount of stocks(% of population) of Morocco?
Keep it short and to the point. 0.78. What is the difference between the highest and the second highest Amount of stocks(% of population) of Sao Tome and Principe?
Ensure brevity in your answer.  1.67. What is the difference between the highest and the lowest Amount of stocks(% of population) in Italy?
Ensure brevity in your answer.  2.52. What is the difference between the highest and the lowest Amount of stocks(% of population) in Morocco?
Offer a terse response. 1.38. What is the difference between the highest and the lowest Amount of stocks(% of population) in Sao Tome and Principe?
Offer a terse response. 7.17. 